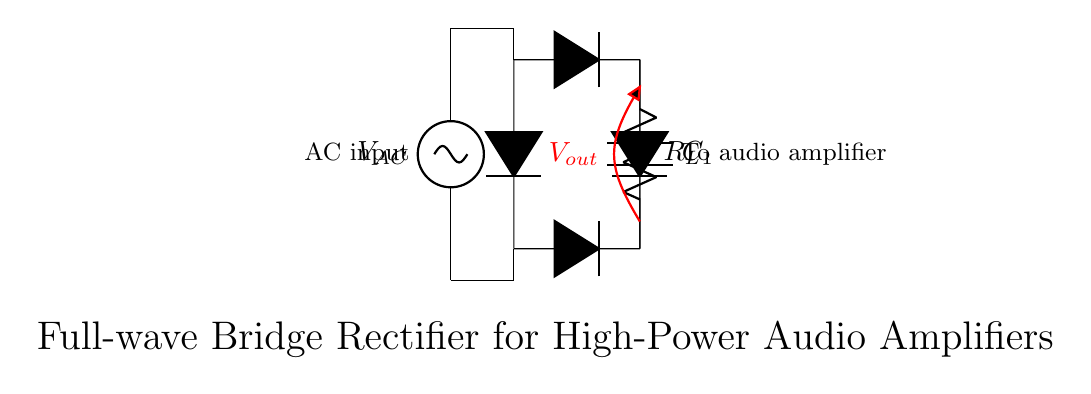What type of rectifier is shown in the circuit? The circuit diagram depicts a full-wave bridge rectifier, which consists of four diodes arranged in a bridge configuration. This allows it to convert both halves of the AC waveform into DC voltage.
Answer: Full-wave bridge rectifier What is the role of the capacitor in this circuit? The capacitor, labeled C1, serves to smooth out the rectified output voltage, reducing ripples and providing a more stable DC voltage to the load. This is crucial for high-power audio amplifiers that require steady voltage for optimal performance.
Answer: Smoothing What is the output voltage denoted as in the circuit? The output voltage is represented by Vout, which indicates the voltage level available at the output terminals of the rectifier after the AC has been converted to DC. It is measured across the load resistor.
Answer: Vout How many diodes are used in this bridge rectifier? The bridge rectifier configuration in the circuit uses a total of four diodes, which work together to ensure that current flows through the load in the same direction during both halves of the AC cycle.
Answer: Four What happens to the AC input when it passes through the bridge rectifier? The AC input voltage, Vin, undergoes conversion to a unidirectional voltage output (DC) when it passes through the diodes of the bridge rectifier, effectively transforming the alternating current into direct current.
Answer: Converts to DC What is indicated by the label Rl in the circuit? Rl denotes the load resistor, which represents the component or system that consumes the power from the rectified output. In high-power audio amplifiers, this would typically be connected to the next stage of amplification.
Answer: Load resistor 